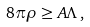Convert formula to latex. <formula><loc_0><loc_0><loc_500><loc_500>8 \pi \rho \geq A \Lambda \, ,</formula> 